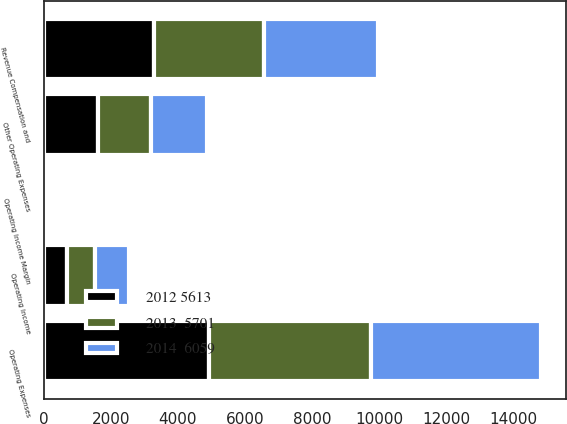Convert chart to OTSL. <chart><loc_0><loc_0><loc_500><loc_500><stacked_bar_chart><ecel><fcel>Revenue Compensation and<fcel>Other Operating Expenses<fcel>Operating Expenses<fcel>Operating Income<fcel>Operating Income Margin<nl><fcel>2014  6059<fcel>3398<fcel>1665<fcel>5063<fcel>996<fcel>16.4<nl><fcel>2013  5701<fcel>3269<fcel>1587<fcel>4856<fcel>845<fcel>14.8<nl><fcel>2012 5613<fcel>3298<fcel>1623<fcel>4921<fcel>692<fcel>12.3<nl></chart> 